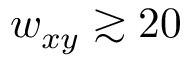<formula> <loc_0><loc_0><loc_500><loc_500>w _ { x y } \gtrsim 2 0</formula> 